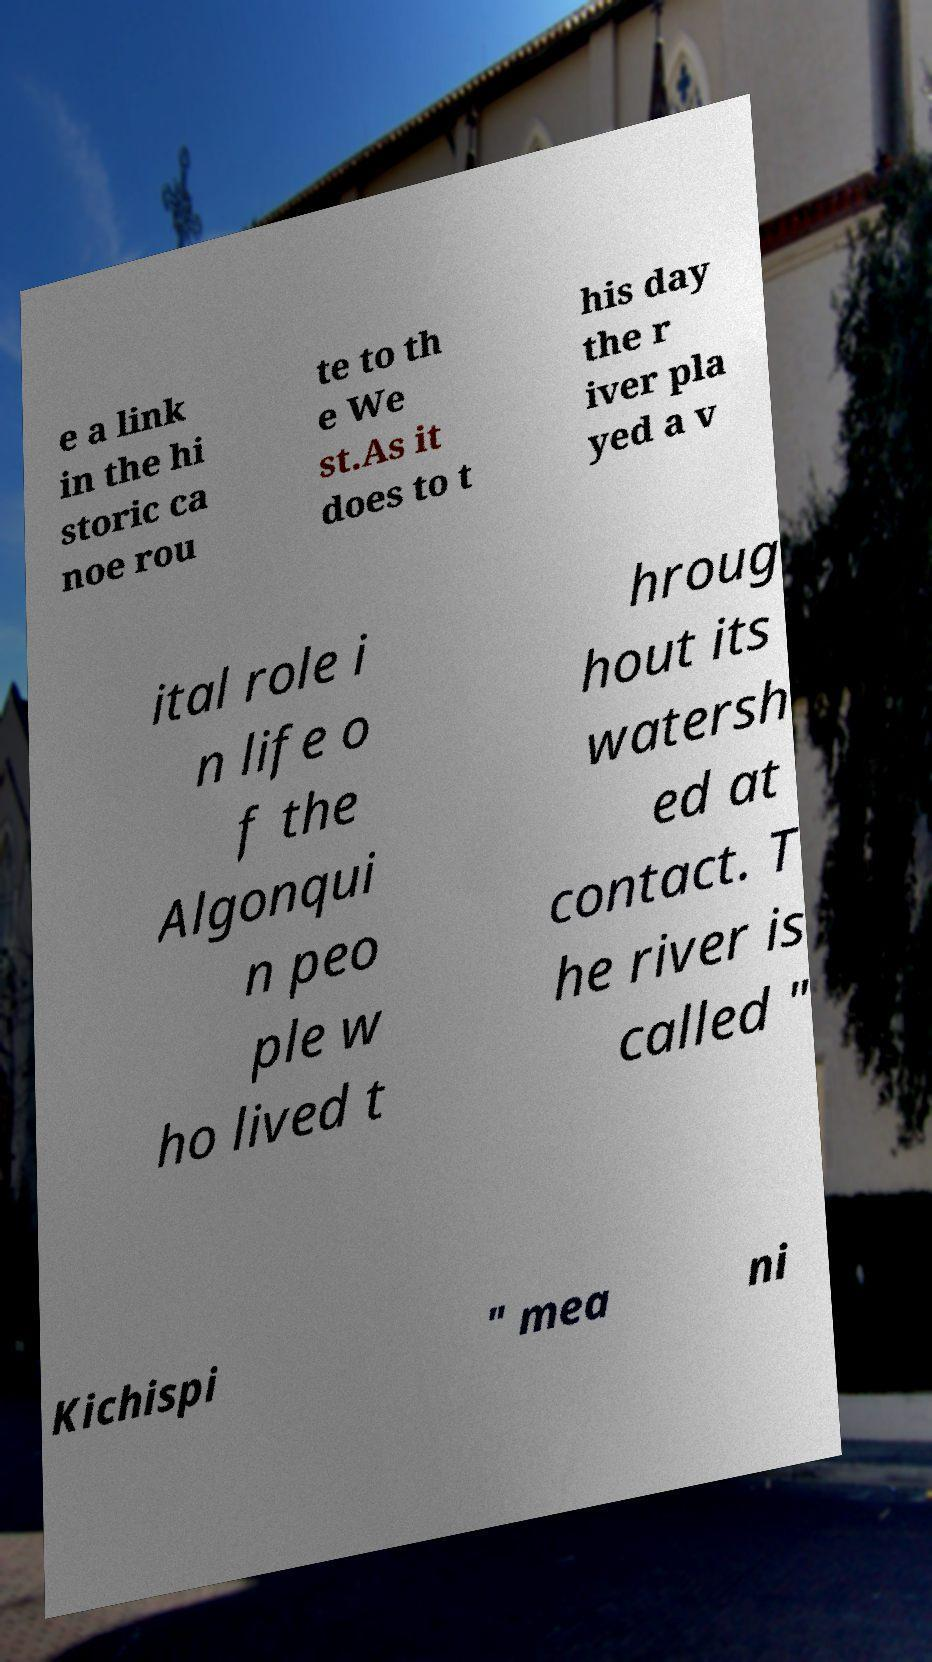Can you read and provide the text displayed in the image?This photo seems to have some interesting text. Can you extract and type it out for me? e a link in the hi storic ca noe rou te to th e We st.As it does to t his day the r iver pla yed a v ital role i n life o f the Algonqui n peo ple w ho lived t hroug hout its watersh ed at contact. T he river is called " Kichispi " mea ni 